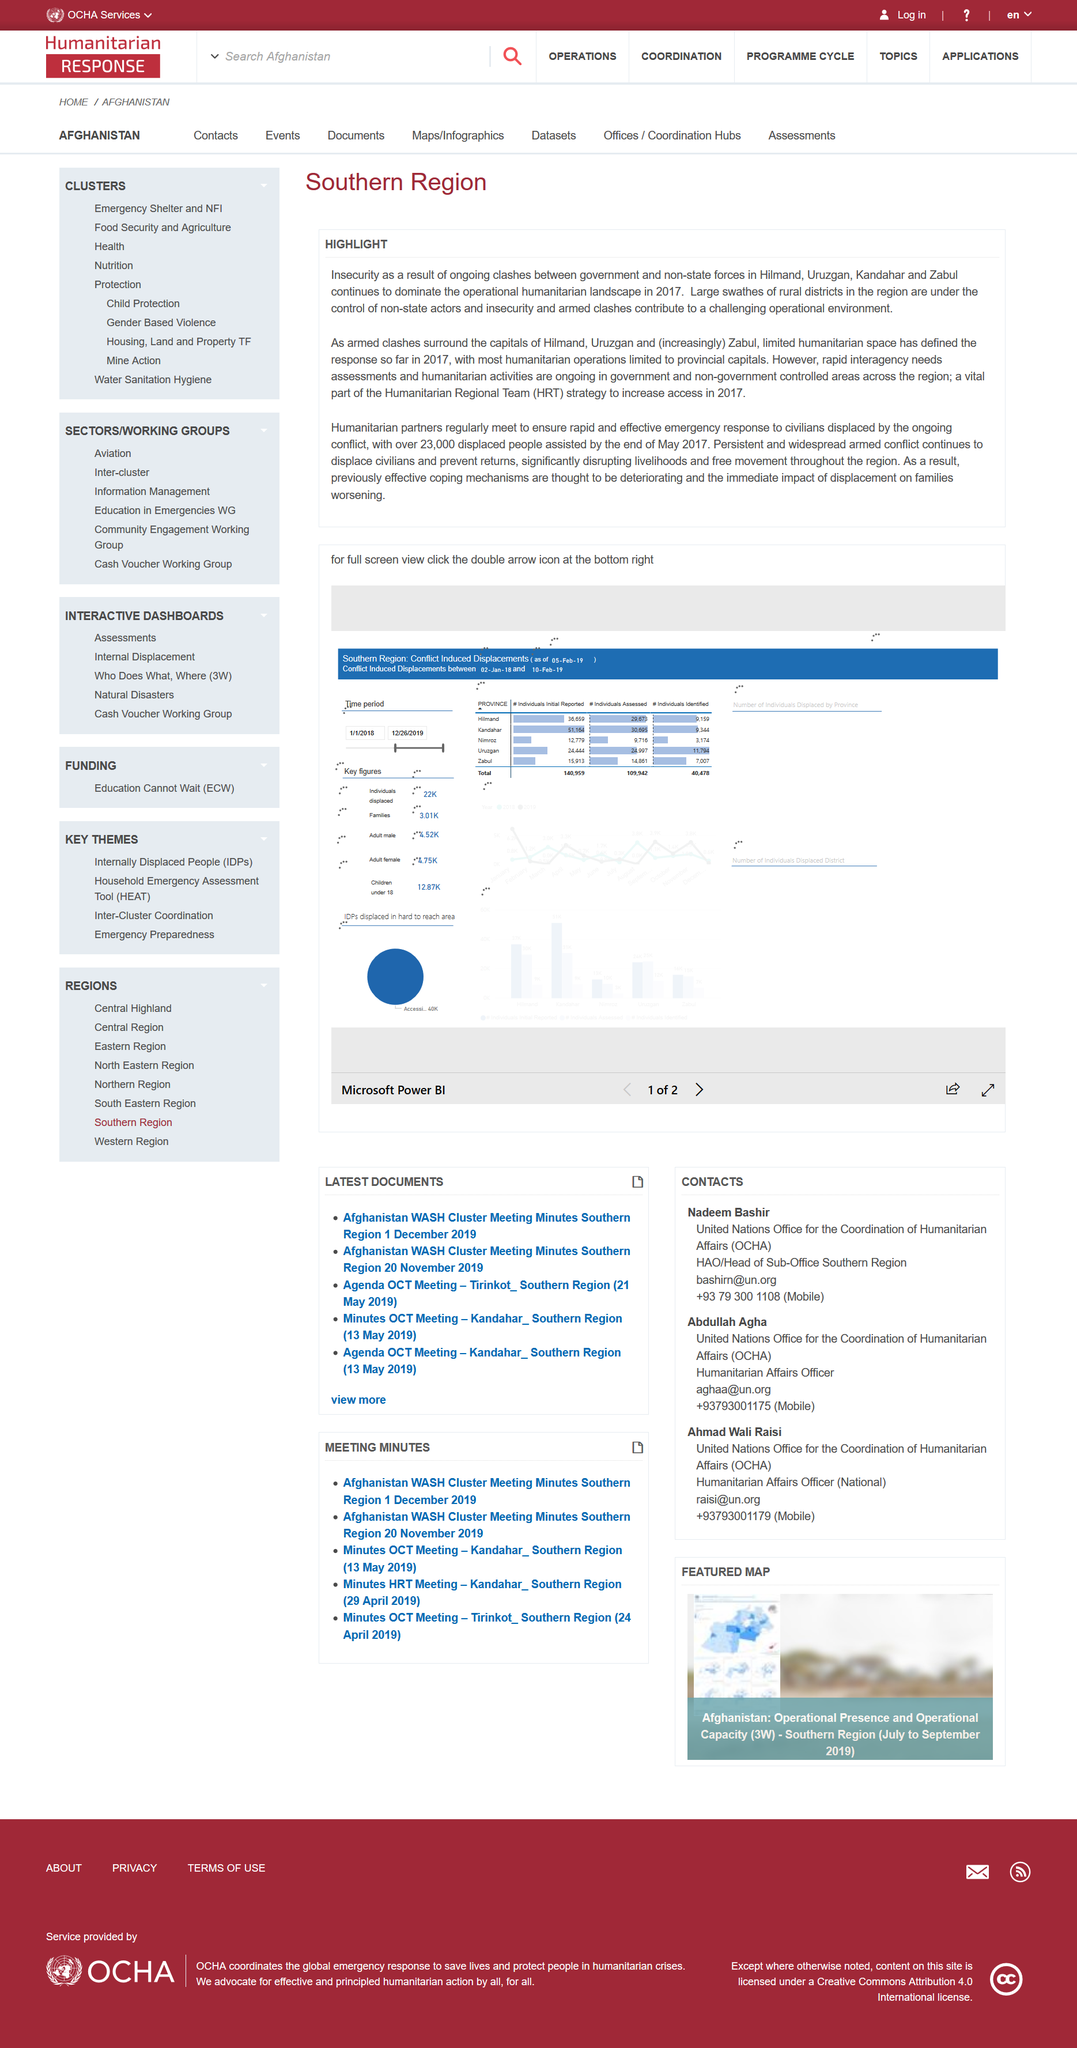Give some essential details in this illustration. Disrupting livelihoods and free movement throughout the region has resulted in the deterioration of previously effective coping mechanisms and the worsening of the immediate impact of displacement on families. Our humanitarian regional team strategy for increasing access in 2017 included conducting rapid interagency needs assessments and implementing humanitarian activities in collaboration with government and non-government organizations across the region. The largest swathes of rural districts in the region are controlled by non-state actors, and insecurity and armed clashes contribute to a challenge to the operational environment. 